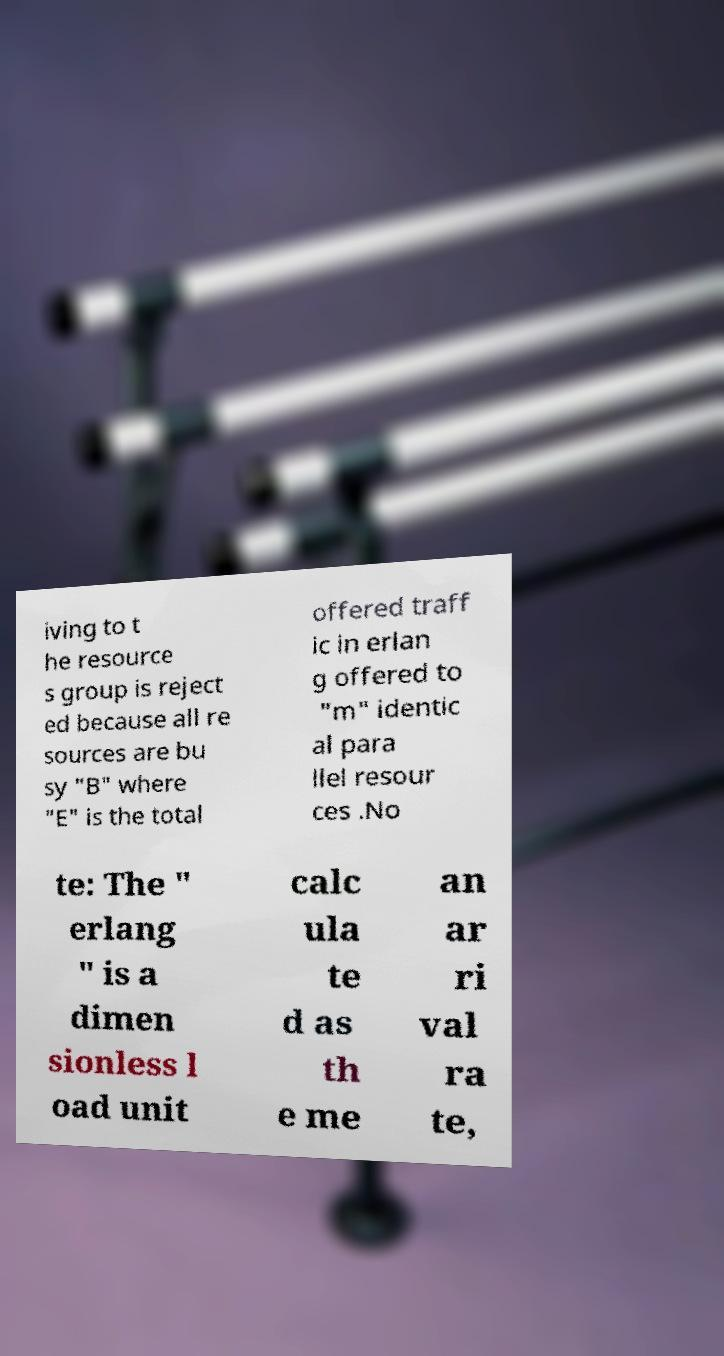There's text embedded in this image that I need extracted. Can you transcribe it verbatim? iving to t he resource s group is reject ed because all re sources are bu sy "B" where "E" is the total offered traff ic in erlan g offered to "m" identic al para llel resour ces .No te: The " erlang " is a dimen sionless l oad unit calc ula te d as th e me an ar ri val ra te, 